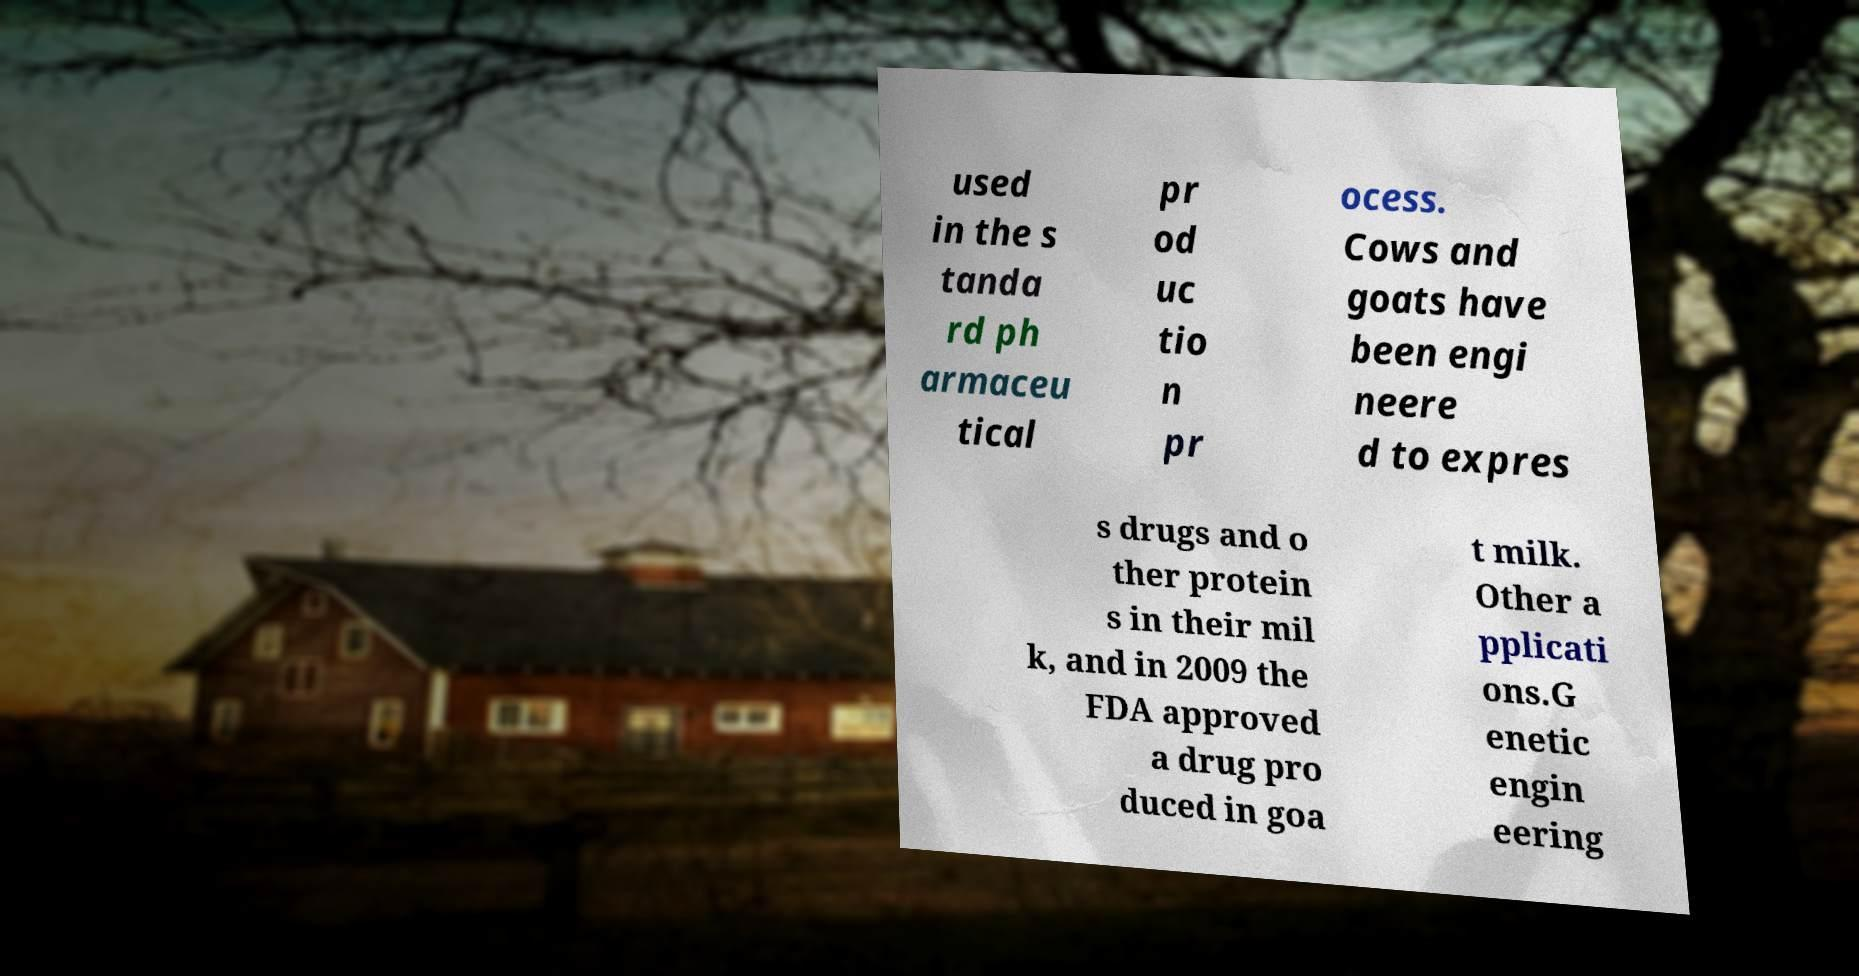What messages or text are displayed in this image? I need them in a readable, typed format. used in the s tanda rd ph armaceu tical pr od uc tio n pr ocess. Cows and goats have been engi neere d to expres s drugs and o ther protein s in their mil k, and in 2009 the FDA approved a drug pro duced in goa t milk. Other a pplicati ons.G enetic engin eering 